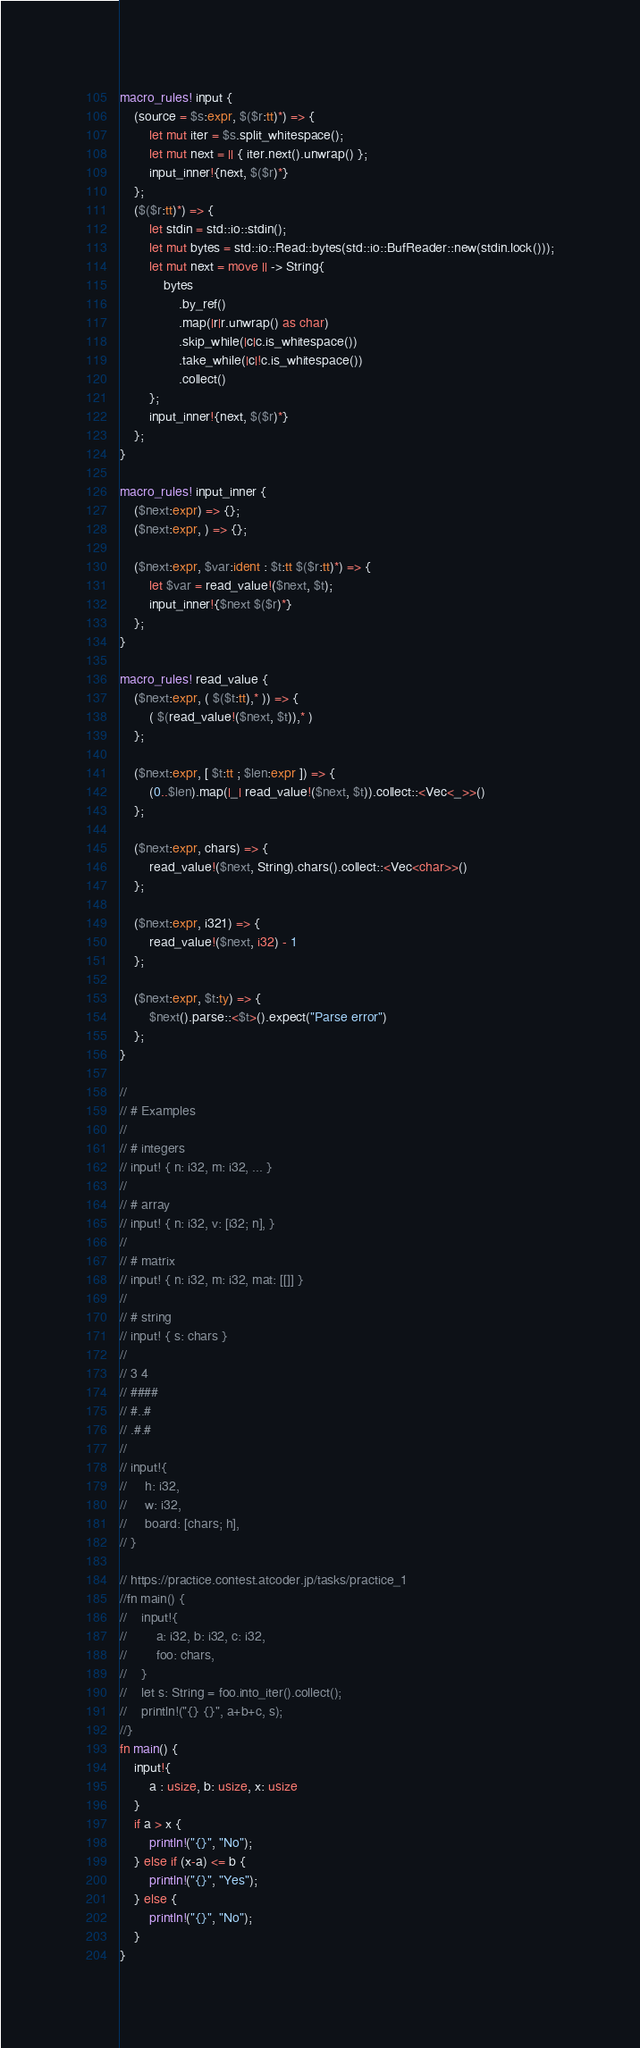Convert code to text. <code><loc_0><loc_0><loc_500><loc_500><_Rust_>macro_rules! input {
    (source = $s:expr, $($r:tt)*) => {
        let mut iter = $s.split_whitespace();
        let mut next = || { iter.next().unwrap() };
        input_inner!{next, $($r)*}
    };
    ($($r:tt)*) => {
        let stdin = std::io::stdin();
        let mut bytes = std::io::Read::bytes(std::io::BufReader::new(stdin.lock()));
        let mut next = move || -> String{
            bytes
                .by_ref()
                .map(|r|r.unwrap() as char)
                .skip_while(|c|c.is_whitespace())
                .take_while(|c|!c.is_whitespace())
                .collect()
        };
        input_inner!{next, $($r)*}
    };
}

macro_rules! input_inner {
    ($next:expr) => {};
    ($next:expr, ) => {};

    ($next:expr, $var:ident : $t:tt $($r:tt)*) => {
        let $var = read_value!($next, $t);
        input_inner!{$next $($r)*}
    };
}

macro_rules! read_value {
    ($next:expr, ( $($t:tt),* )) => {
        ( $(read_value!($next, $t)),* )
    };

    ($next:expr, [ $t:tt ; $len:expr ]) => {
        (0..$len).map(|_| read_value!($next, $t)).collect::<Vec<_>>()
    };

    ($next:expr, chars) => {
        read_value!($next, String).chars().collect::<Vec<char>>()
    };

    ($next:expr, i321) => {
        read_value!($next, i32) - 1
    };

    ($next:expr, $t:ty) => {
        $next().parse::<$t>().expect("Parse error")
    };
}

//
// # Examples
//
// # integers
// input! { n: i32, m: i32, ... }
//
// # array
// input! { n: i32, v: [i32; n], }
//
// # matrix
// input! { n: i32, m: i32, mat: [[]] }
//
// # string
// input! { s: chars }
//
// 3 4
// ####
// #..#
// .#.#
//
// input!{
//     h: i32,
//     w: i32,
//     board: [chars; h],
// }

// https://practice.contest.atcoder.jp/tasks/practice_1
//fn main() {
//    input!{
//        a: i32, b: i32, c: i32,
//        foo: chars,
//    }
//    let s: String = foo.into_iter().collect();
//    println!("{} {}", a+b+c, s);
//}
fn main() {
    input!{
        a : usize, b: usize, x: usize
    }
    if a > x {
        println!("{}", "No");
    } else if (x-a) <= b {
        println!("{}", "Yes");
    } else {
        println!("{}", "No");
    }
}</code> 